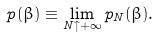Convert formula to latex. <formula><loc_0><loc_0><loc_500><loc_500>p ( \beta ) \equiv \lim _ { N \uparrow + \infty } p _ { N } ( \beta ) .</formula> 